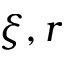Convert formula to latex. <formula><loc_0><loc_0><loc_500><loc_500>\xi , r</formula> 